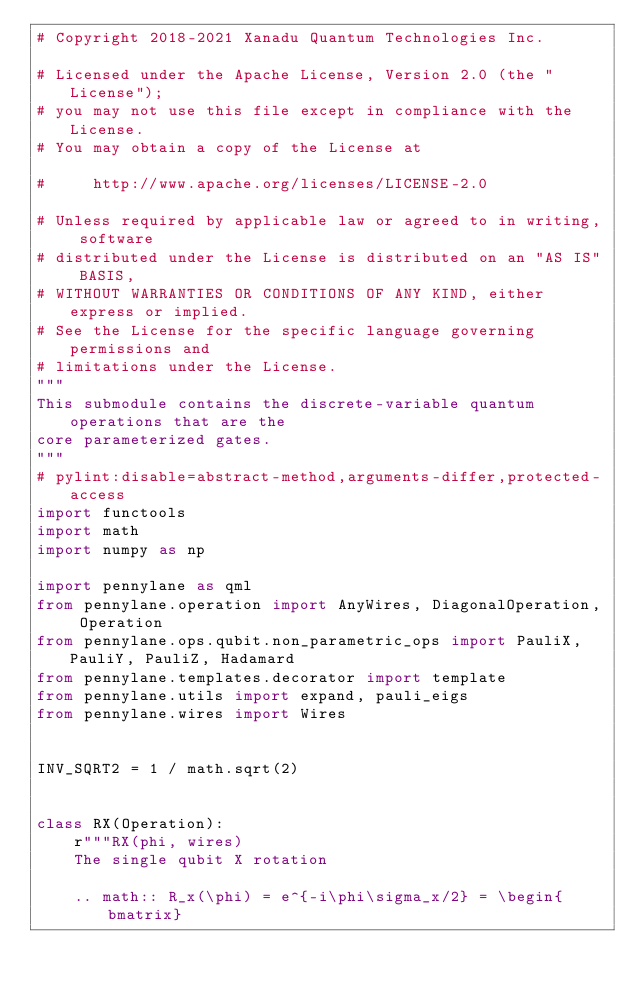Convert code to text. <code><loc_0><loc_0><loc_500><loc_500><_Python_># Copyright 2018-2021 Xanadu Quantum Technologies Inc.

# Licensed under the Apache License, Version 2.0 (the "License");
# you may not use this file except in compliance with the License.
# You may obtain a copy of the License at

#     http://www.apache.org/licenses/LICENSE-2.0

# Unless required by applicable law or agreed to in writing, software
# distributed under the License is distributed on an "AS IS" BASIS,
# WITHOUT WARRANTIES OR CONDITIONS OF ANY KIND, either express or implied.
# See the License for the specific language governing permissions and
# limitations under the License.
"""
This submodule contains the discrete-variable quantum operations that are the
core parameterized gates.
"""
# pylint:disable=abstract-method,arguments-differ,protected-access
import functools
import math
import numpy as np

import pennylane as qml
from pennylane.operation import AnyWires, DiagonalOperation, Operation
from pennylane.ops.qubit.non_parametric_ops import PauliX, PauliY, PauliZ, Hadamard
from pennylane.templates.decorator import template
from pennylane.utils import expand, pauli_eigs
from pennylane.wires import Wires


INV_SQRT2 = 1 / math.sqrt(2)


class RX(Operation):
    r"""RX(phi, wires)
    The single qubit X rotation

    .. math:: R_x(\phi) = e^{-i\phi\sigma_x/2} = \begin{bmatrix}</code> 